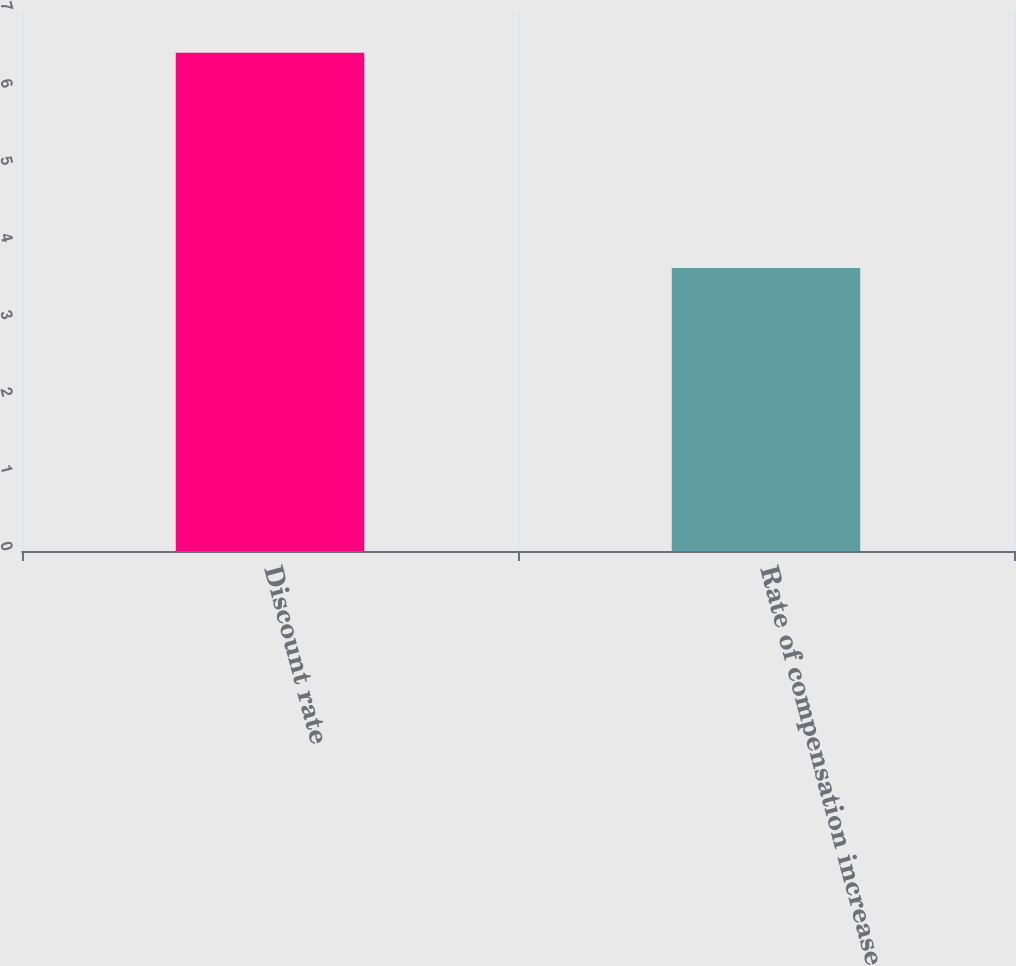Convert chart. <chart><loc_0><loc_0><loc_500><loc_500><bar_chart><fcel>Discount rate<fcel>Rate of compensation increase<nl><fcel>6.46<fcel>3.67<nl></chart> 